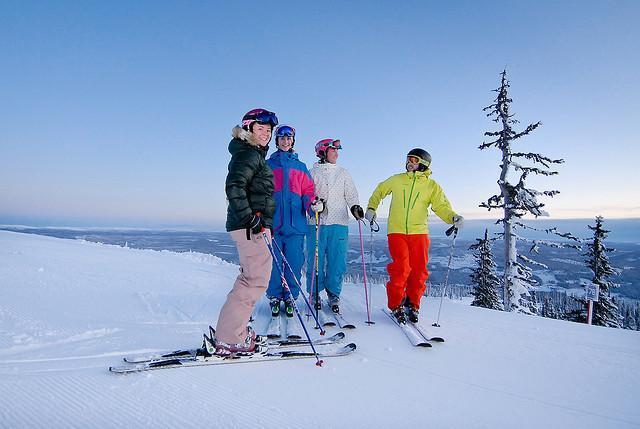How many people are there?
Give a very brief answer. 4. How many people are here?
Give a very brief answer. 4. How many people are in the picture?
Give a very brief answer. 4. How many giraffe are walking in the grass?
Give a very brief answer. 0. 